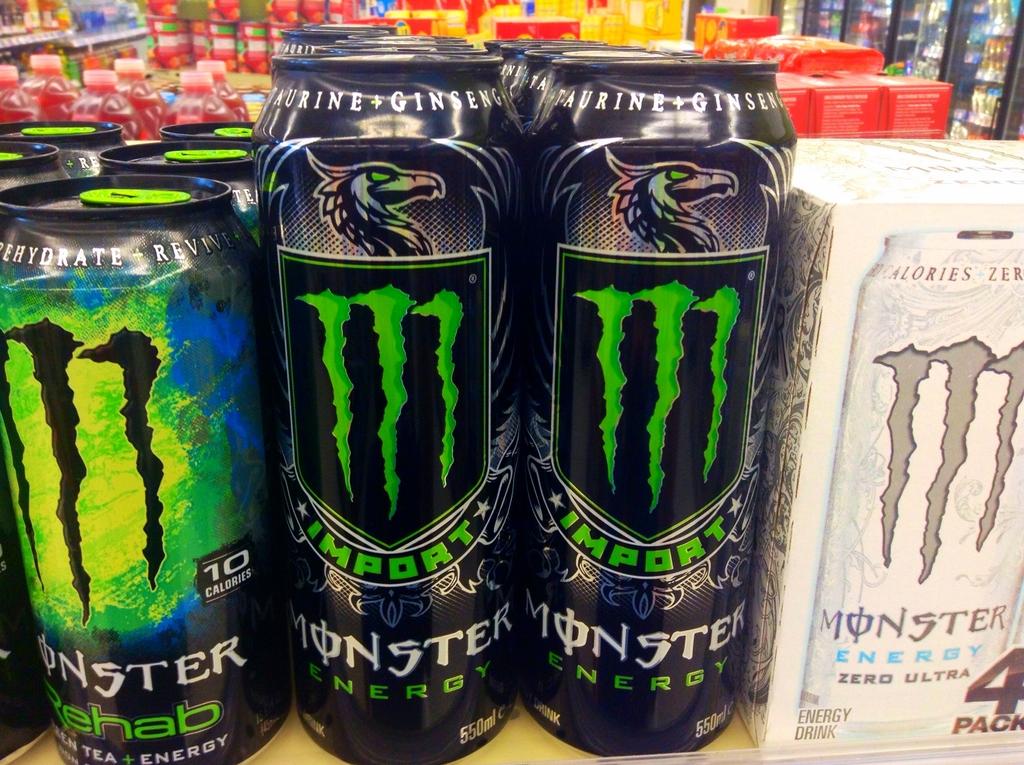What color is monster imports logo?
Your response must be concise. Green. What is the monster drink that is white?
Offer a very short reply. Zero ultra. 